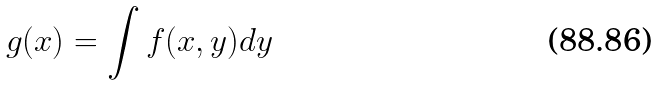Convert formula to latex. <formula><loc_0><loc_0><loc_500><loc_500>g ( x ) = \int f ( x , y ) d y</formula> 